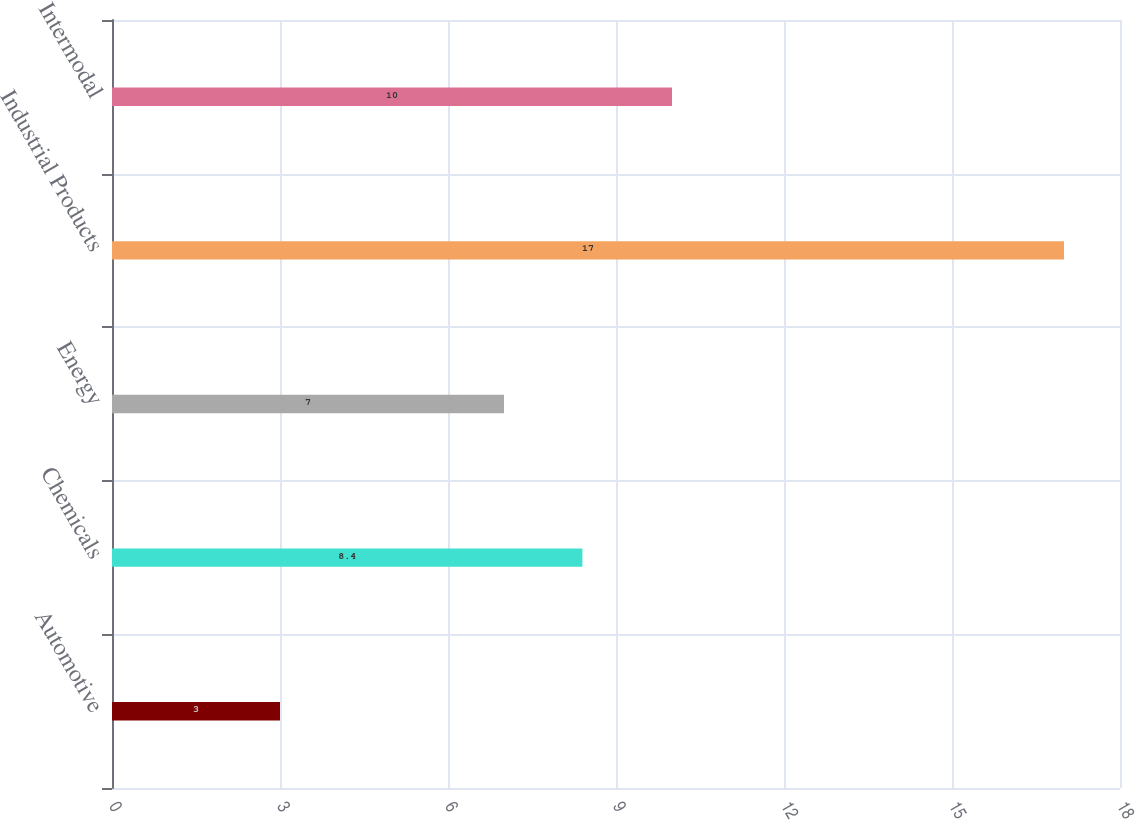Convert chart. <chart><loc_0><loc_0><loc_500><loc_500><bar_chart><fcel>Automotive<fcel>Chemicals<fcel>Energy<fcel>Industrial Products<fcel>Intermodal<nl><fcel>3<fcel>8.4<fcel>7<fcel>17<fcel>10<nl></chart> 